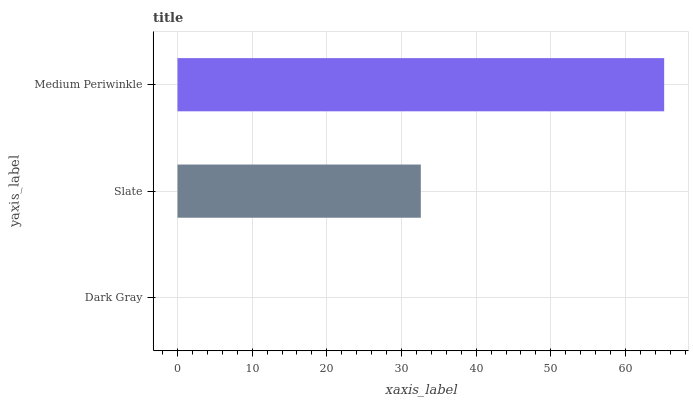Is Dark Gray the minimum?
Answer yes or no. Yes. Is Medium Periwinkle the maximum?
Answer yes or no. Yes. Is Slate the minimum?
Answer yes or no. No. Is Slate the maximum?
Answer yes or no. No. Is Slate greater than Dark Gray?
Answer yes or no. Yes. Is Dark Gray less than Slate?
Answer yes or no. Yes. Is Dark Gray greater than Slate?
Answer yes or no. No. Is Slate less than Dark Gray?
Answer yes or no. No. Is Slate the high median?
Answer yes or no. Yes. Is Slate the low median?
Answer yes or no. Yes. Is Medium Periwinkle the high median?
Answer yes or no. No. Is Medium Periwinkle the low median?
Answer yes or no. No. 